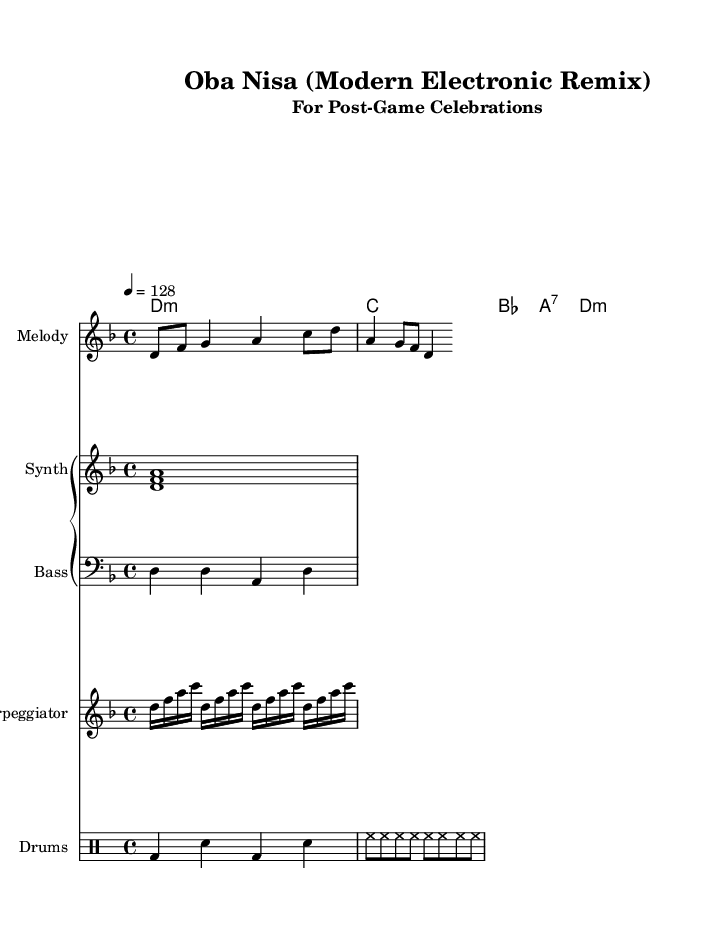What is the key signature of this music? The key signature indicates the key of D minor, which has one flat. This is determined by observing the key signature at the beginning of the music sheet, where a flat is indicated on the B line.
Answer: D minor What is the time signature of this music? The time signature shown is 4/4, which means there are four beats in each measure. This can be identified from the notation at the beginning that specifies how the beats in each measure are organized.
Answer: 4/4 What is the tempo marking for this piece? The tempo marking is 128 beats per minute, indicated by the text "4 = 128" above the staff. This means the quarter note gets one beat, and the tempo is set to a moderate pace.
Answer: 128 How many measures are in the melody? The melody consists of only one measure as indicated by the repeated notes and the ending shape of the melody line. As you count the notes within the single four beats, it aligns with one full measure of 4/4 time.
Answer: 1 What type of drum instruments are indicated in the score? The score specifies a "DrumStaff" and uses standard drum notation, indicating that the piece includes bass drums and snare drums along with hi-hats, which are typical in electronic remixes.
Answer: Bass drum and snare drum What are the chords used in the piece? The chords listed in the chord section are D minor, C major, B flat major, A seventh, and D minor. These can be identified by reading the chord symbols to the left of the staff, which outline the harmony used throughout the piece.
Answer: D minor, C, B flat, A seventh 